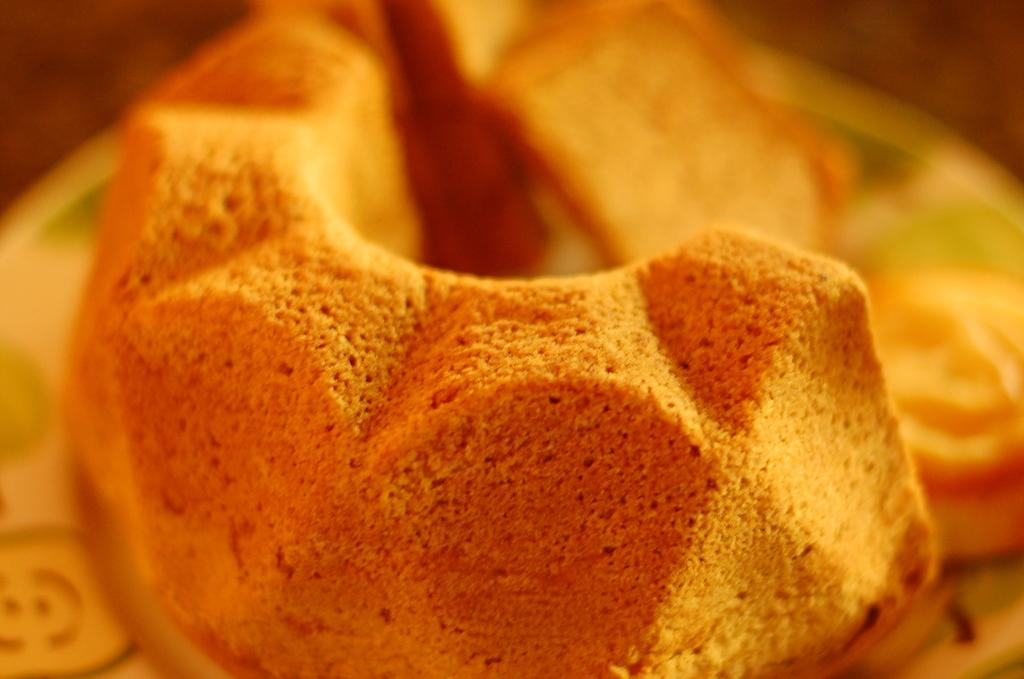What can be seen in the image? There is an object in the image. What scientific discovery is being advertised by the uncle in the image? There is no scientific discovery or uncle present in the image; it only contains an object. 